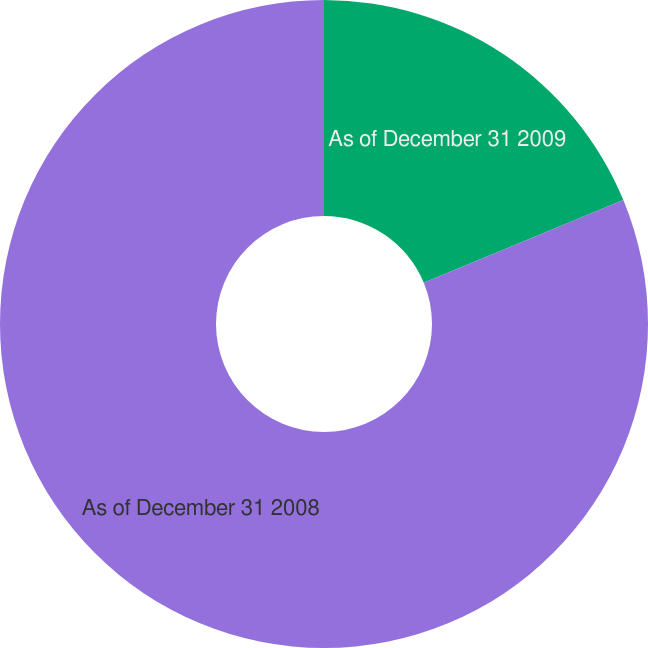Convert chart. <chart><loc_0><loc_0><loc_500><loc_500><pie_chart><fcel>As of December 31 2009<fcel>As of December 31 2008<nl><fcel>18.75%<fcel>81.25%<nl></chart> 